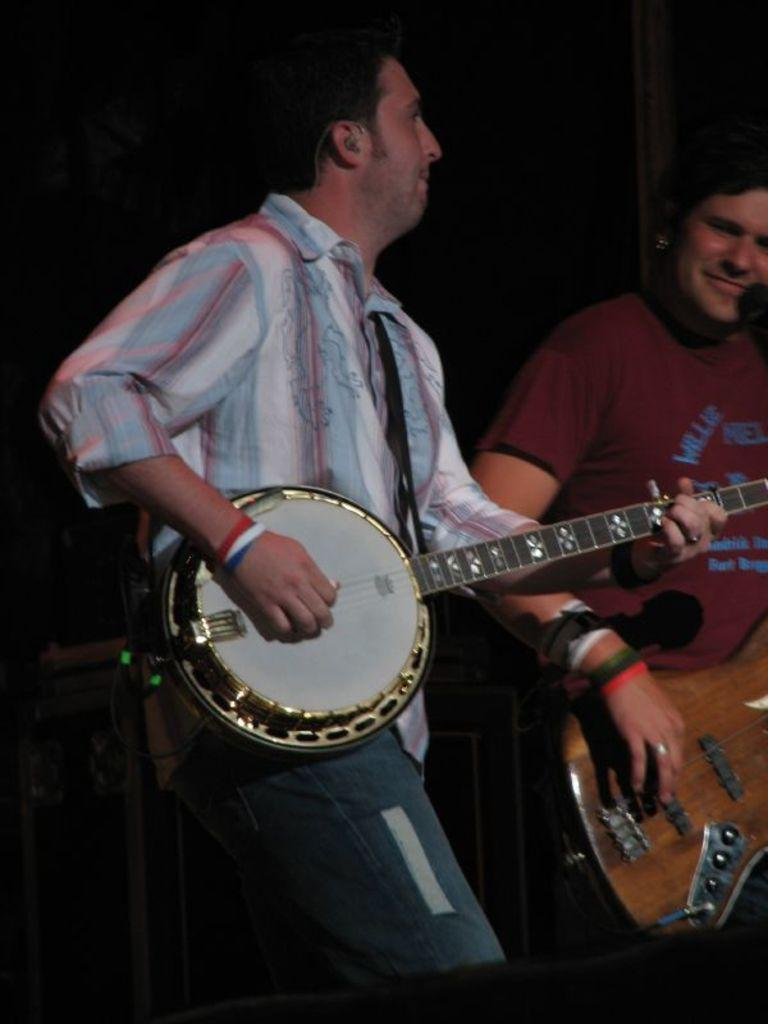How many people are in the image? There are two people in the image. What are the two people doing in the image? The two people are playing musical instruments. How many fingers does the force use to make the people cough in the image? There is no force or coughing depicted in the image; it features two people playing musical instruments. 